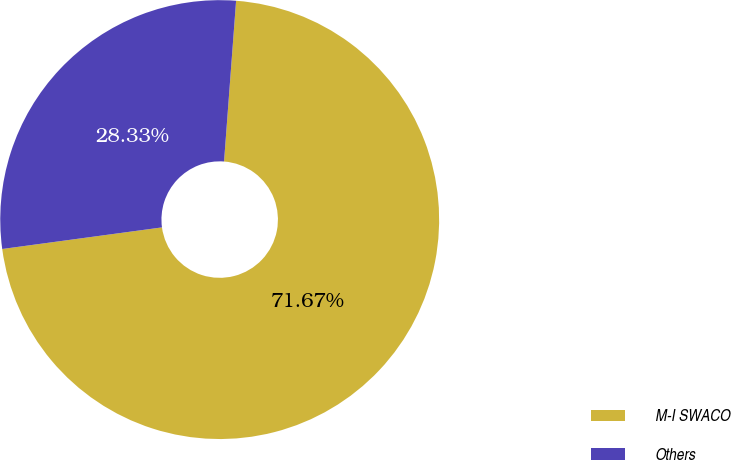Convert chart. <chart><loc_0><loc_0><loc_500><loc_500><pie_chart><fcel>M-I SWACO<fcel>Others<nl><fcel>71.67%<fcel>28.33%<nl></chart> 